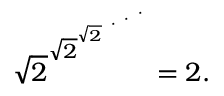<formula> <loc_0><loc_0><loc_500><loc_500>{ \sqrt { 2 } } ^ { { \sqrt { 2 } } ^ { { \sqrt { 2 } } ^ { \cdot ^ { \cdot ^ { \cdot } } } } } = 2 .</formula> 